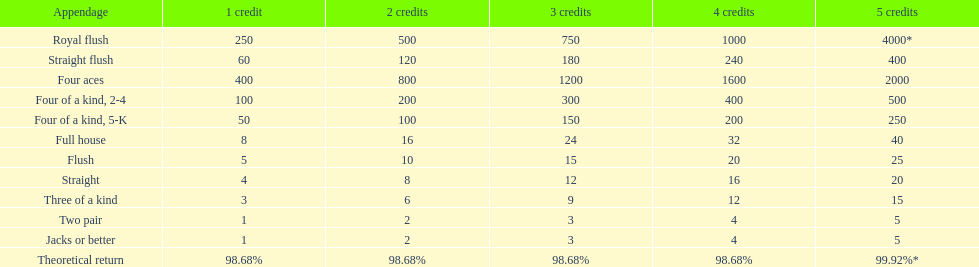The number of flush wins at one credit to equal one flush win at 5 credits. 5. 